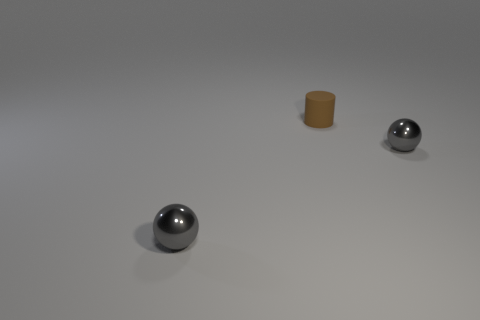What number of other objects are the same material as the brown cylinder?
Make the answer very short. 0. Are there fewer brown matte cylinders than gray metallic objects?
Provide a succinct answer. Yes. Are the cylinder and the small gray object to the left of the brown object made of the same material?
Give a very brief answer. No. What is the shape of the tiny gray object on the left side of the brown thing?
Offer a terse response. Sphere. Is there any other thing that has the same color as the small cylinder?
Offer a terse response. No. Is the number of tiny rubber cylinders that are behind the matte cylinder less than the number of objects?
Ensure brevity in your answer.  Yes. How many gray metal spheres have the same size as the brown cylinder?
Provide a succinct answer. 2. There is a tiny gray metallic object in front of the small gray metal ball that is behind the tiny metallic thing to the left of the brown cylinder; what is its shape?
Offer a terse response. Sphere. There is a tiny shiny sphere that is left of the tiny cylinder; what is its color?
Make the answer very short. Gray. What number of objects are either small shiny spheres right of the small rubber cylinder or tiny metallic spheres right of the brown thing?
Make the answer very short. 1. 